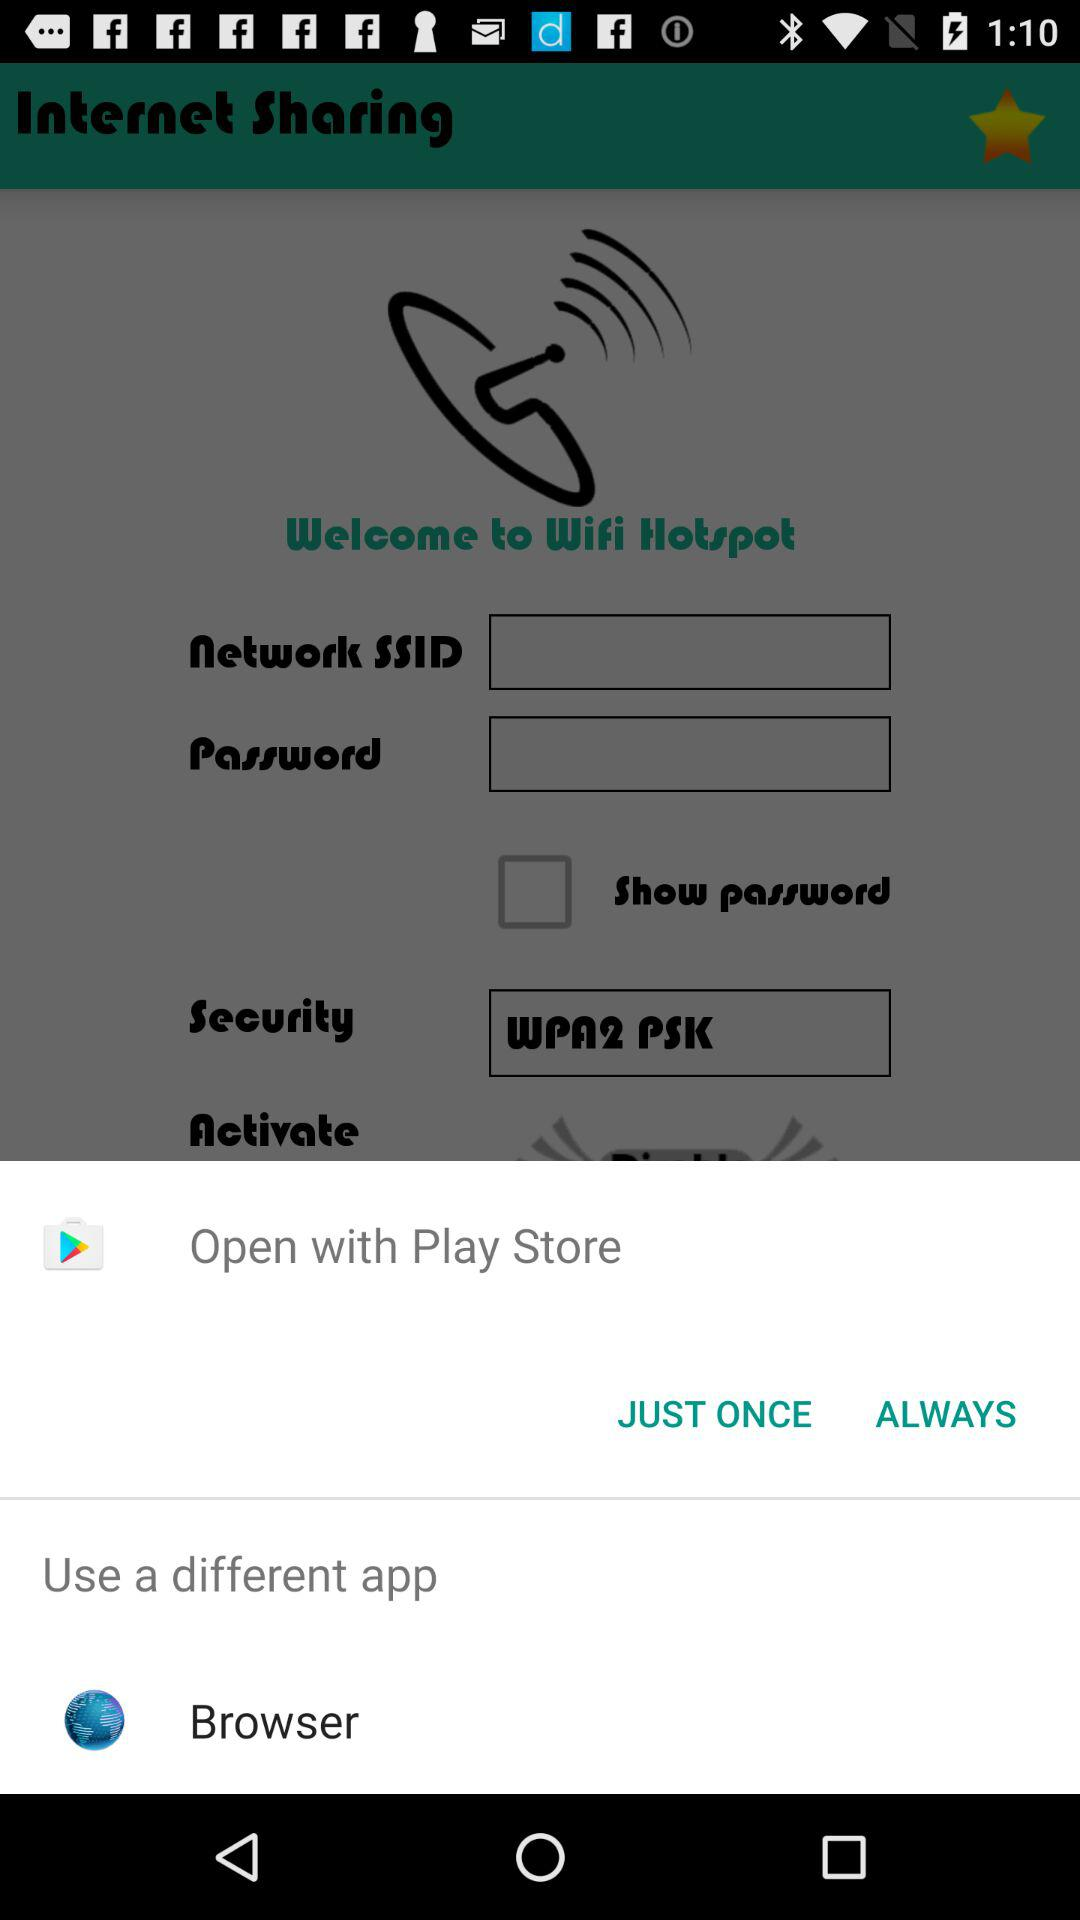Which application can I use to open the content? The applications that you can use to open the content are "Play Store" and "Browser". 